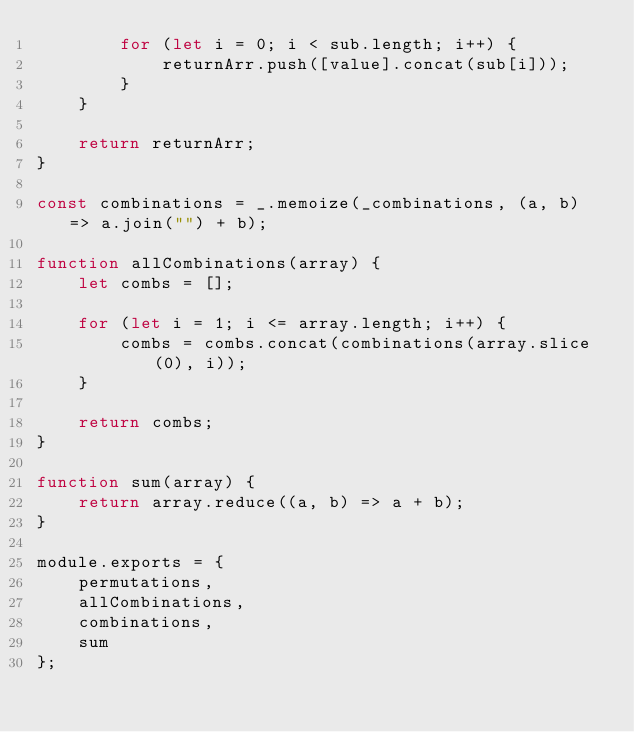<code> <loc_0><loc_0><loc_500><loc_500><_JavaScript_>        for (let i = 0; i < sub.length; i++) {
            returnArr.push([value].concat(sub[i]));
        }
    }

    return returnArr;
}

const combinations = _.memoize(_combinations, (a, b) => a.join("") + b);

function allCombinations(array) {
    let combs = [];

    for (let i = 1; i <= array.length; i++) {
        combs = combs.concat(combinations(array.slice(0), i));
    }

    return combs;
}

function sum(array) {
    return array.reduce((a, b) => a + b);
}

module.exports = {
    permutations,
    allCombinations,
    combinations,
    sum
};
</code> 